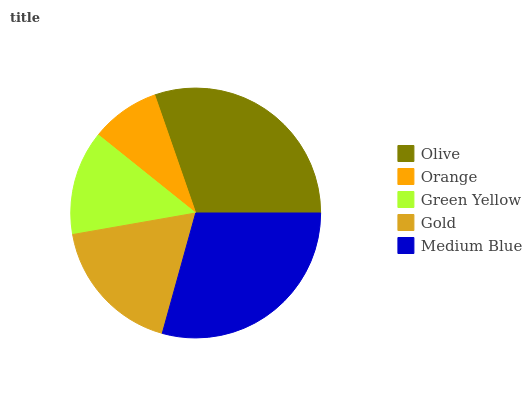Is Orange the minimum?
Answer yes or no. Yes. Is Olive the maximum?
Answer yes or no. Yes. Is Green Yellow the minimum?
Answer yes or no. No. Is Green Yellow the maximum?
Answer yes or no. No. Is Green Yellow greater than Orange?
Answer yes or no. Yes. Is Orange less than Green Yellow?
Answer yes or no. Yes. Is Orange greater than Green Yellow?
Answer yes or no. No. Is Green Yellow less than Orange?
Answer yes or no. No. Is Gold the high median?
Answer yes or no. Yes. Is Gold the low median?
Answer yes or no. Yes. Is Green Yellow the high median?
Answer yes or no. No. Is Green Yellow the low median?
Answer yes or no. No. 